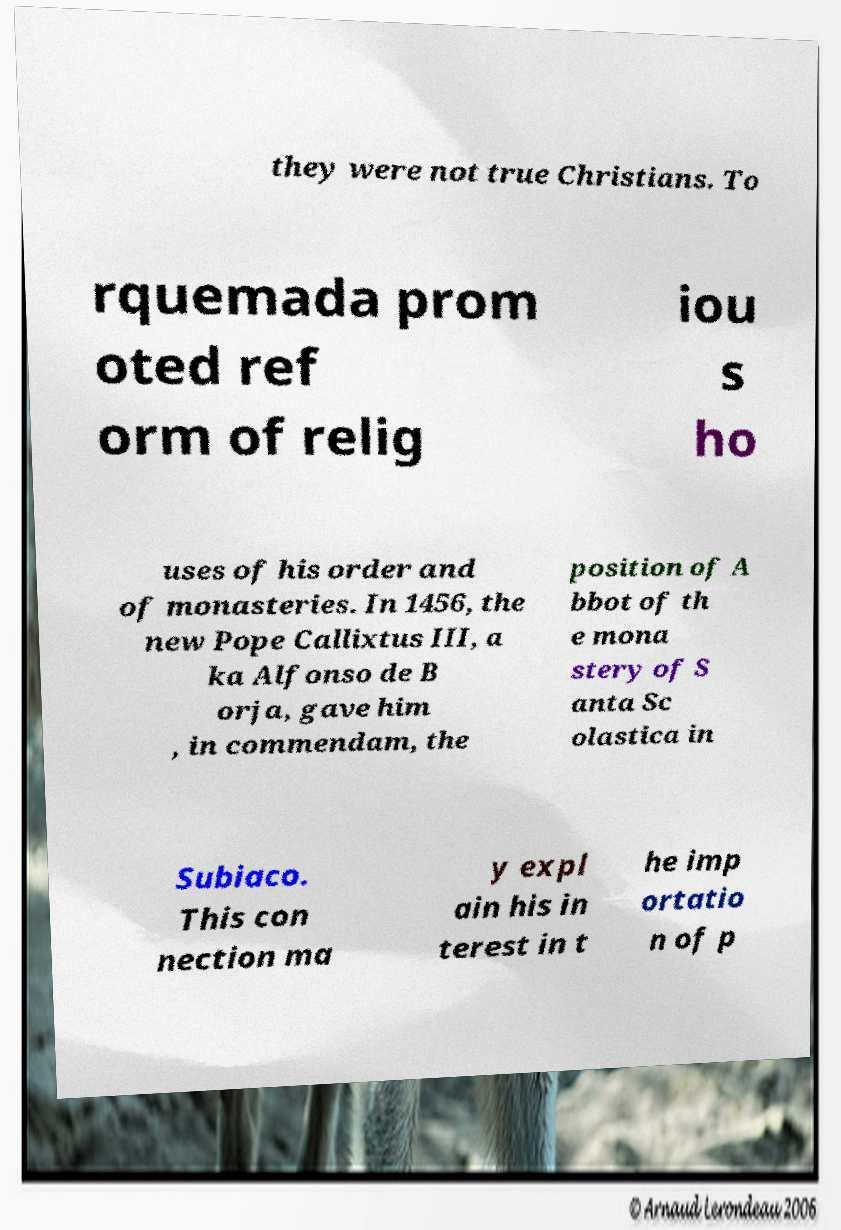What messages or text are displayed in this image? I need them in a readable, typed format. they were not true Christians. To rquemada prom oted ref orm of relig iou s ho uses of his order and of monasteries. In 1456, the new Pope Callixtus III, a ka Alfonso de B orja, gave him , in commendam, the position of A bbot of th e mona stery of S anta Sc olastica in Subiaco. This con nection ma y expl ain his in terest in t he imp ortatio n of p 